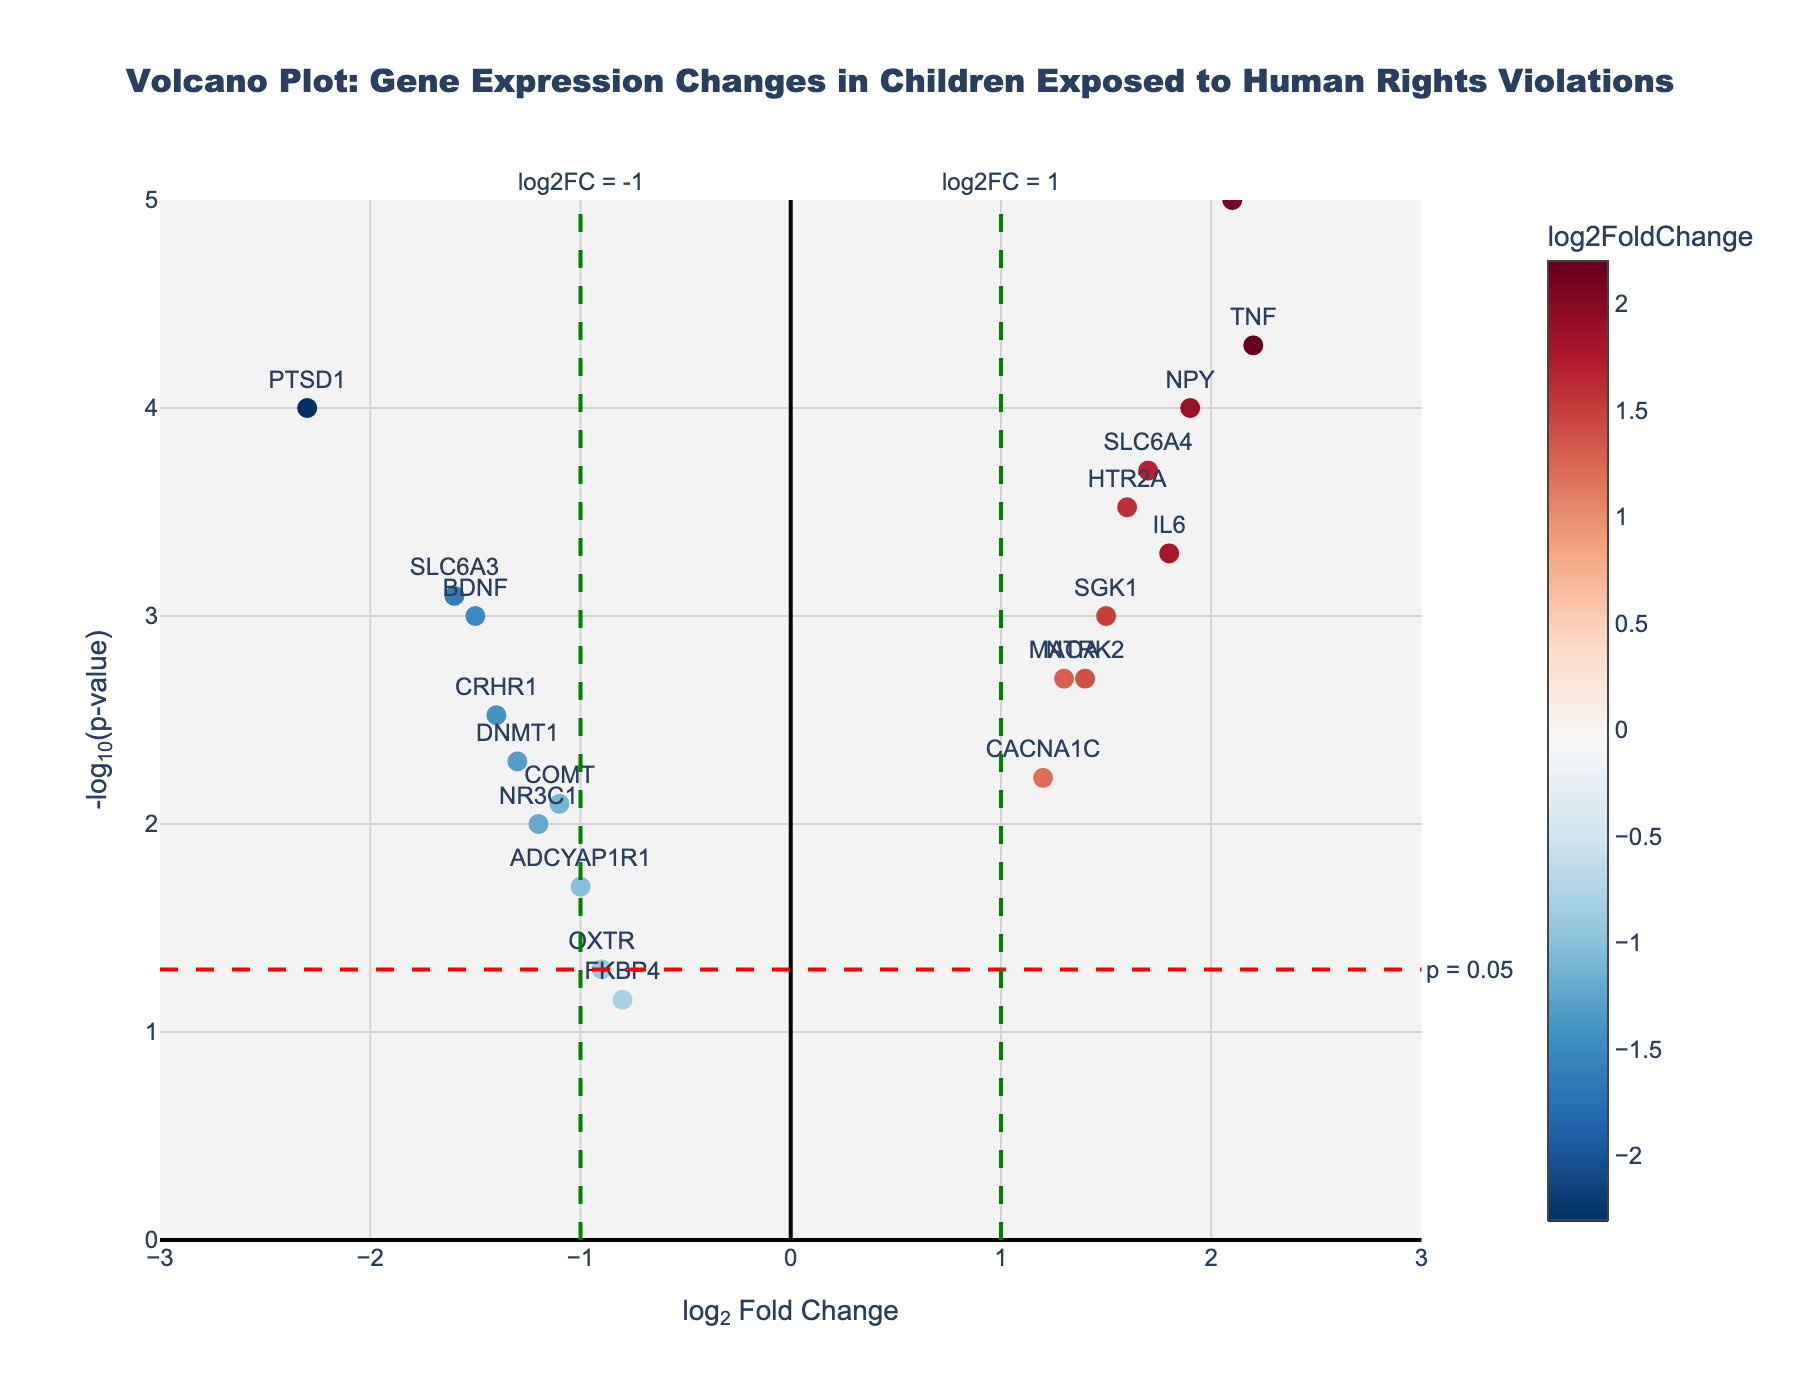What's the title of the figure? Look at the top of the figure. The title is usually positioned at the top center and describes the main subject of the plot.
Answer: Volcano Plot: Gene Expression Changes in Children Exposed to Human Rights Violations What does the x-axis represent? Look for the label on the horizontal axis. It typically describes what is plotted along the x-axis.
Answer: log2 Fold Change What does the y-axis represent? Look for the label on the vertical axis. It usually tells you what is plotted on the y-axis.
Answer: -log10(p-value) How many genes show a positive log2 fold change greater than 1? Identify genes with log2 fold change values greater than 1 on the right side of the plot. Count those points.
Answer: Five Which gene has the highest -log10(p-value) and what is its value? Find the point with the highest value on the y-axis and identify the corresponding gene. Check the y-axis value and the hover info.
Answer: FKBP5, around 5 Which gene has the most significant down-regulation? Look for the gene with the lowest log2 fold change on the left side of the x-axis and check the p-value to ensure it’s significant (indicated by the height on the y-axis).
Answer: PTSD1 Compare the expression changes of IL6 and TNF. Which one has a higher log2 fold change and which one has a lower p-value? Locate IL6 (log2FC = 1.8, p-value = 0.0005) and TNF (log2FC = 2.2, p-value = 0.00005) on the plot. TNF has a higher log2 fold change and a lower p-value.
Answer: TNF has a higher log2 fold change and lower p-value How many genes have p-values less than 0.01? Identify all points above the y = -log10(0.01) threshold line. Count how many points are above this line.
Answer: Fourteen What are the coordinates of the OXTR gene point on the plot? Look for the OXTR gene on the plot and note its position related to the x and y axes.
Answer: (-0.9, ~1.3) Which genes are more highly expressed in exposed children compared to non-exposed, based on log2 fold change? Identify genes with positive log2 fold change values (right side of the plot).
Answer: IL6, FKBP5, SLC6A4, MAOA, HTR2A, NPY, TNF, SGK1, CACNA1C, NTRK2 